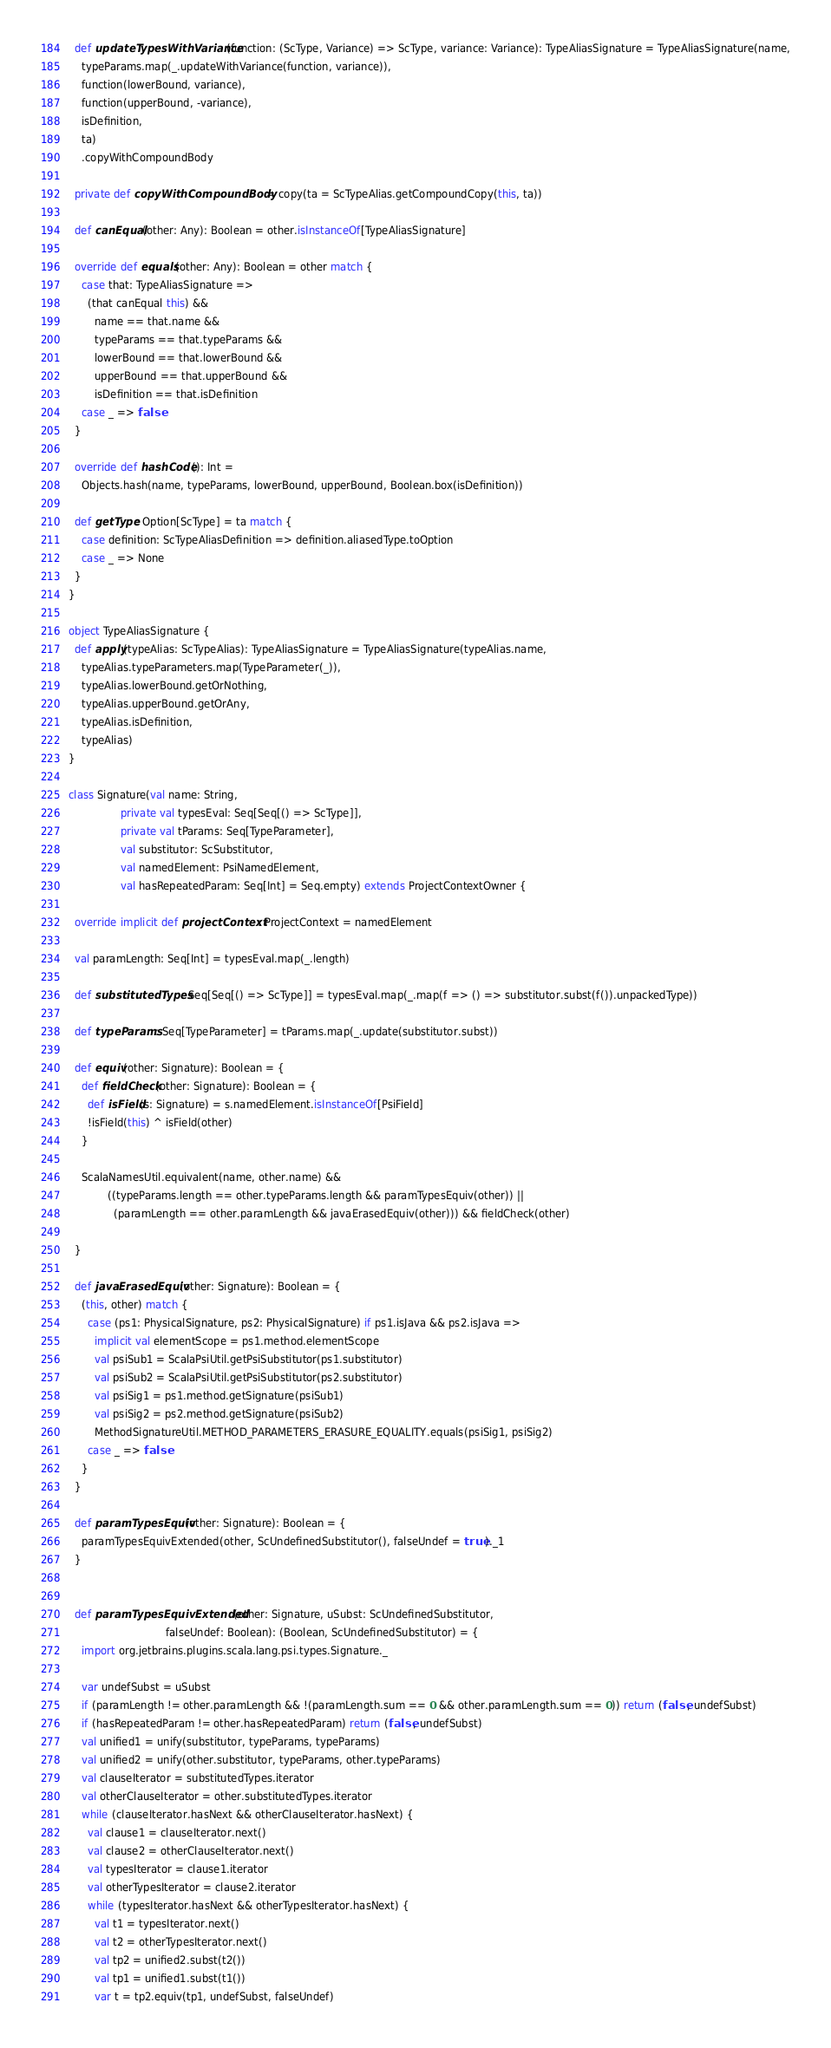Convert code to text. <code><loc_0><loc_0><loc_500><loc_500><_Scala_>
  def updateTypesWithVariance(function: (ScType, Variance) => ScType, variance: Variance): TypeAliasSignature = TypeAliasSignature(name,
    typeParams.map(_.updateWithVariance(function, variance)),
    function(lowerBound, variance),
    function(upperBound, -variance),
    isDefinition,
    ta)
    .copyWithCompoundBody

  private def copyWithCompoundBody = copy(ta = ScTypeAlias.getCompoundCopy(this, ta))

  def canEqual(other: Any): Boolean = other.isInstanceOf[TypeAliasSignature]

  override def equals(other: Any): Boolean = other match {
    case that: TypeAliasSignature =>
      (that canEqual this) &&
        name == that.name &&
        typeParams == that.typeParams &&
        lowerBound == that.lowerBound &&
        upperBound == that.upperBound &&
        isDefinition == that.isDefinition
    case _ => false
  }

  override def hashCode(): Int =
    Objects.hash(name, typeParams, lowerBound, upperBound, Boolean.box(isDefinition))

  def getType: Option[ScType] = ta match {
    case definition: ScTypeAliasDefinition => definition.aliasedType.toOption
    case _ => None
  }
}

object TypeAliasSignature {
  def apply(typeAlias: ScTypeAlias): TypeAliasSignature = TypeAliasSignature(typeAlias.name,
    typeAlias.typeParameters.map(TypeParameter(_)),
    typeAlias.lowerBound.getOrNothing,
    typeAlias.upperBound.getOrAny,
    typeAlias.isDefinition,
    typeAlias)
}

class Signature(val name: String,
                private val typesEval: Seq[Seq[() => ScType]],
                private val tParams: Seq[TypeParameter],
                val substitutor: ScSubstitutor,
                val namedElement: PsiNamedElement,
                val hasRepeatedParam: Seq[Int] = Seq.empty) extends ProjectContextOwner {

  override implicit def projectContext: ProjectContext = namedElement

  val paramLength: Seq[Int] = typesEval.map(_.length)

  def substitutedTypes: Seq[Seq[() => ScType]] = typesEval.map(_.map(f => () => substitutor.subst(f()).unpackedType))

  def typeParams: Seq[TypeParameter] = tParams.map(_.update(substitutor.subst))

  def equiv(other: Signature): Boolean = {
    def fieldCheck(other: Signature): Boolean = {
      def isField(s: Signature) = s.namedElement.isInstanceOf[PsiField]
      !isField(this) ^ isField(other)
    }

    ScalaNamesUtil.equivalent(name, other.name) &&
            ((typeParams.length == other.typeParams.length && paramTypesEquiv(other)) || 
              (paramLength == other.paramLength && javaErasedEquiv(other))) && fieldCheck(other)
    
  }

  def javaErasedEquiv(other: Signature): Boolean = {
    (this, other) match {
      case (ps1: PhysicalSignature, ps2: PhysicalSignature) if ps1.isJava && ps2.isJava =>
        implicit val elementScope = ps1.method.elementScope
        val psiSub1 = ScalaPsiUtil.getPsiSubstitutor(ps1.substitutor)
        val psiSub2 = ScalaPsiUtil.getPsiSubstitutor(ps2.substitutor)
        val psiSig1 = ps1.method.getSignature(psiSub1)
        val psiSig2 = ps2.method.getSignature(psiSub2)
        MethodSignatureUtil.METHOD_PARAMETERS_ERASURE_EQUALITY.equals(psiSig1, psiSig2)
      case _ => false
    }
  }

  def paramTypesEquiv(other: Signature): Boolean = {
    paramTypesEquivExtended(other, ScUndefinedSubstitutor(), falseUndef = true)._1
  }


  def paramTypesEquivExtended(other: Signature, uSubst: ScUndefinedSubstitutor,
                              falseUndef: Boolean): (Boolean, ScUndefinedSubstitutor) = {
    import org.jetbrains.plugins.scala.lang.psi.types.Signature._

    var undefSubst = uSubst
    if (paramLength != other.paramLength && !(paramLength.sum == 0 && other.paramLength.sum == 0)) return (false, undefSubst)
    if (hasRepeatedParam != other.hasRepeatedParam) return (false, undefSubst)
    val unified1 = unify(substitutor, typeParams, typeParams)
    val unified2 = unify(other.substitutor, typeParams, other.typeParams)
    val clauseIterator = substitutedTypes.iterator
    val otherClauseIterator = other.substitutedTypes.iterator
    while (clauseIterator.hasNext && otherClauseIterator.hasNext) {
      val clause1 = clauseIterator.next()
      val clause2 = otherClauseIterator.next()
      val typesIterator = clause1.iterator
      val otherTypesIterator = clause2.iterator
      while (typesIterator.hasNext && otherTypesIterator.hasNext) {
        val t1 = typesIterator.next()
        val t2 = otherTypesIterator.next()
        val tp2 = unified2.subst(t2())
        val tp1 = unified1.subst(t1())
        var t = tp2.equiv(tp1, undefSubst, falseUndef)</code> 